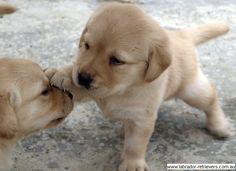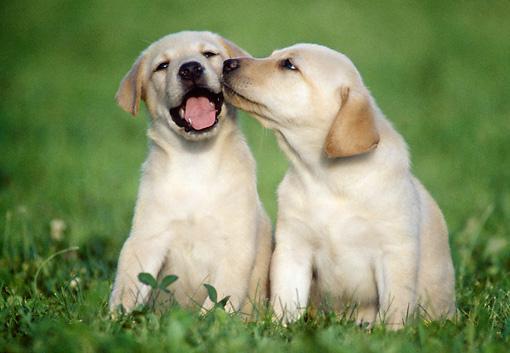The first image is the image on the left, the second image is the image on the right. For the images shown, is this caption "The left image features one golden and one black colored Labrador while the right image contains two chocolate or black lab puppies." true? Answer yes or no. No. The first image is the image on the left, the second image is the image on the right. Assess this claim about the two images: "An adult black dog and younger cream colored dog are together in an interior location, while in a second image, two puppies of the same color and breed snuggle together.". Correct or not? Answer yes or no. No. 